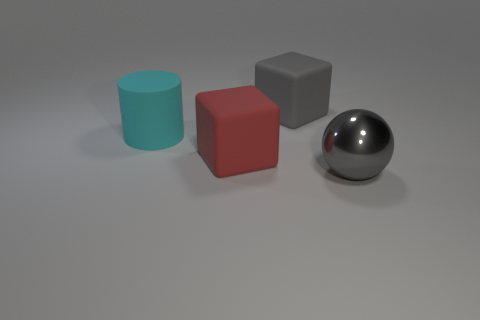Add 1 green cylinders. How many objects exist? 5 Subtract all balls. How many objects are left? 3 Add 1 large gray balls. How many large gray balls exist? 2 Subtract 0 purple spheres. How many objects are left? 4 Subtract all large metal objects. Subtract all large cyan matte objects. How many objects are left? 2 Add 3 big cyan matte objects. How many big cyan matte objects are left? 4 